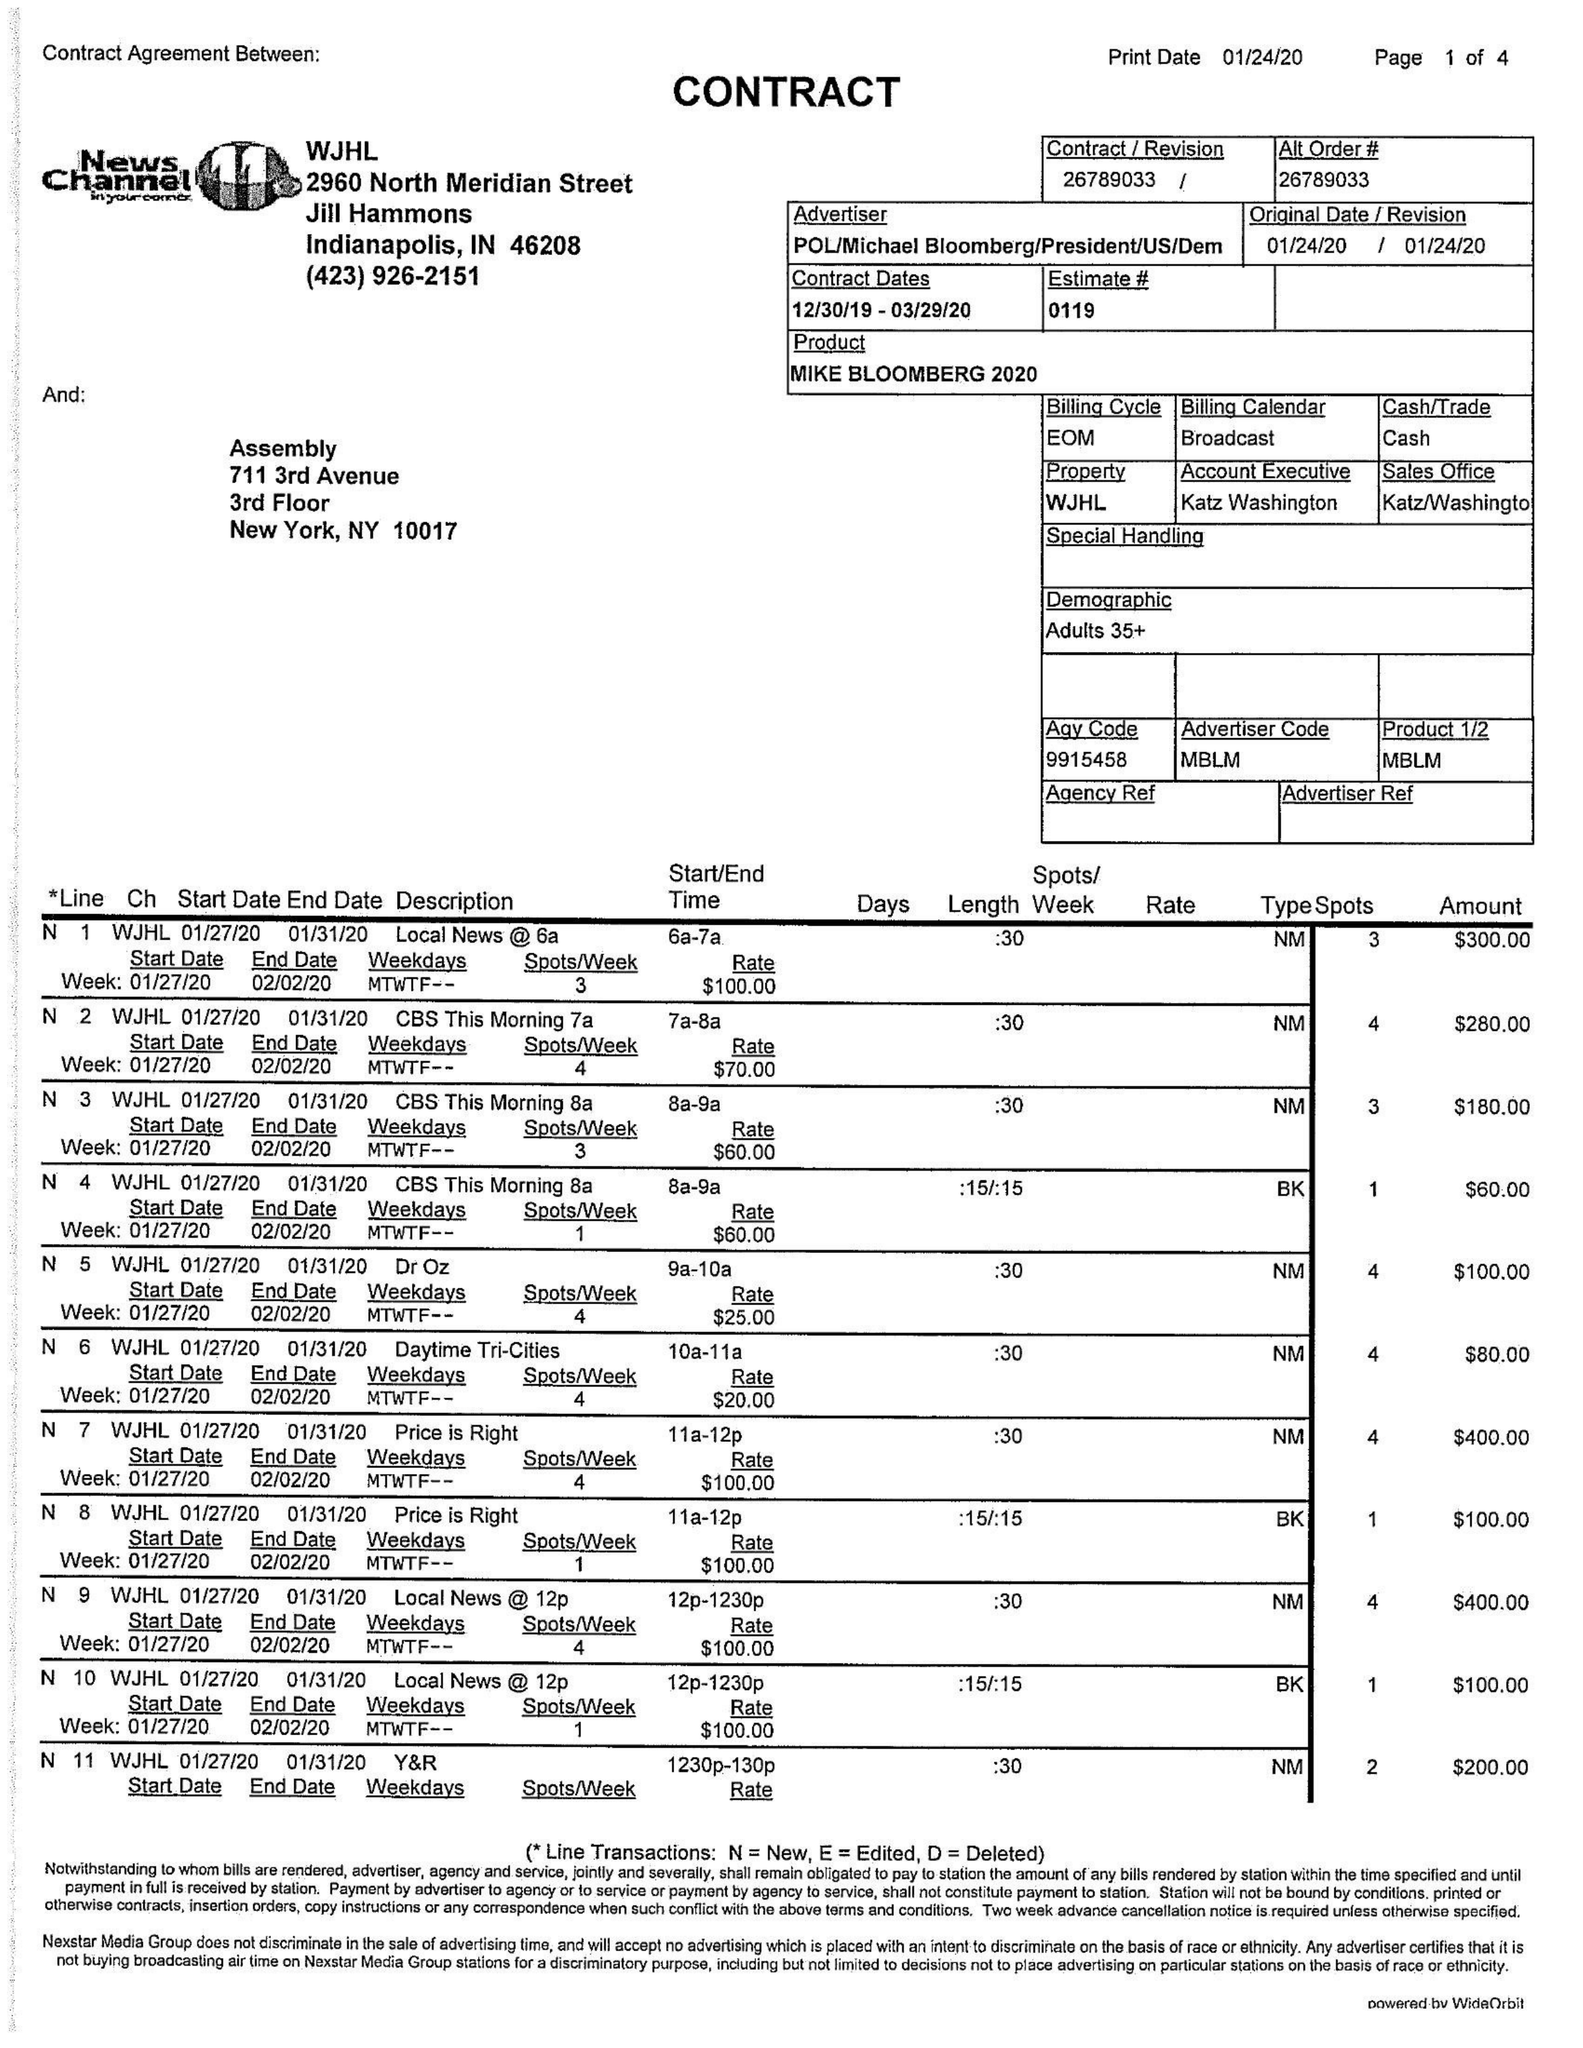What is the value for the advertiser?
Answer the question using a single word or phrase. POL/MICHAELBLOOMBERG/PRESIDENT/US/DEM 